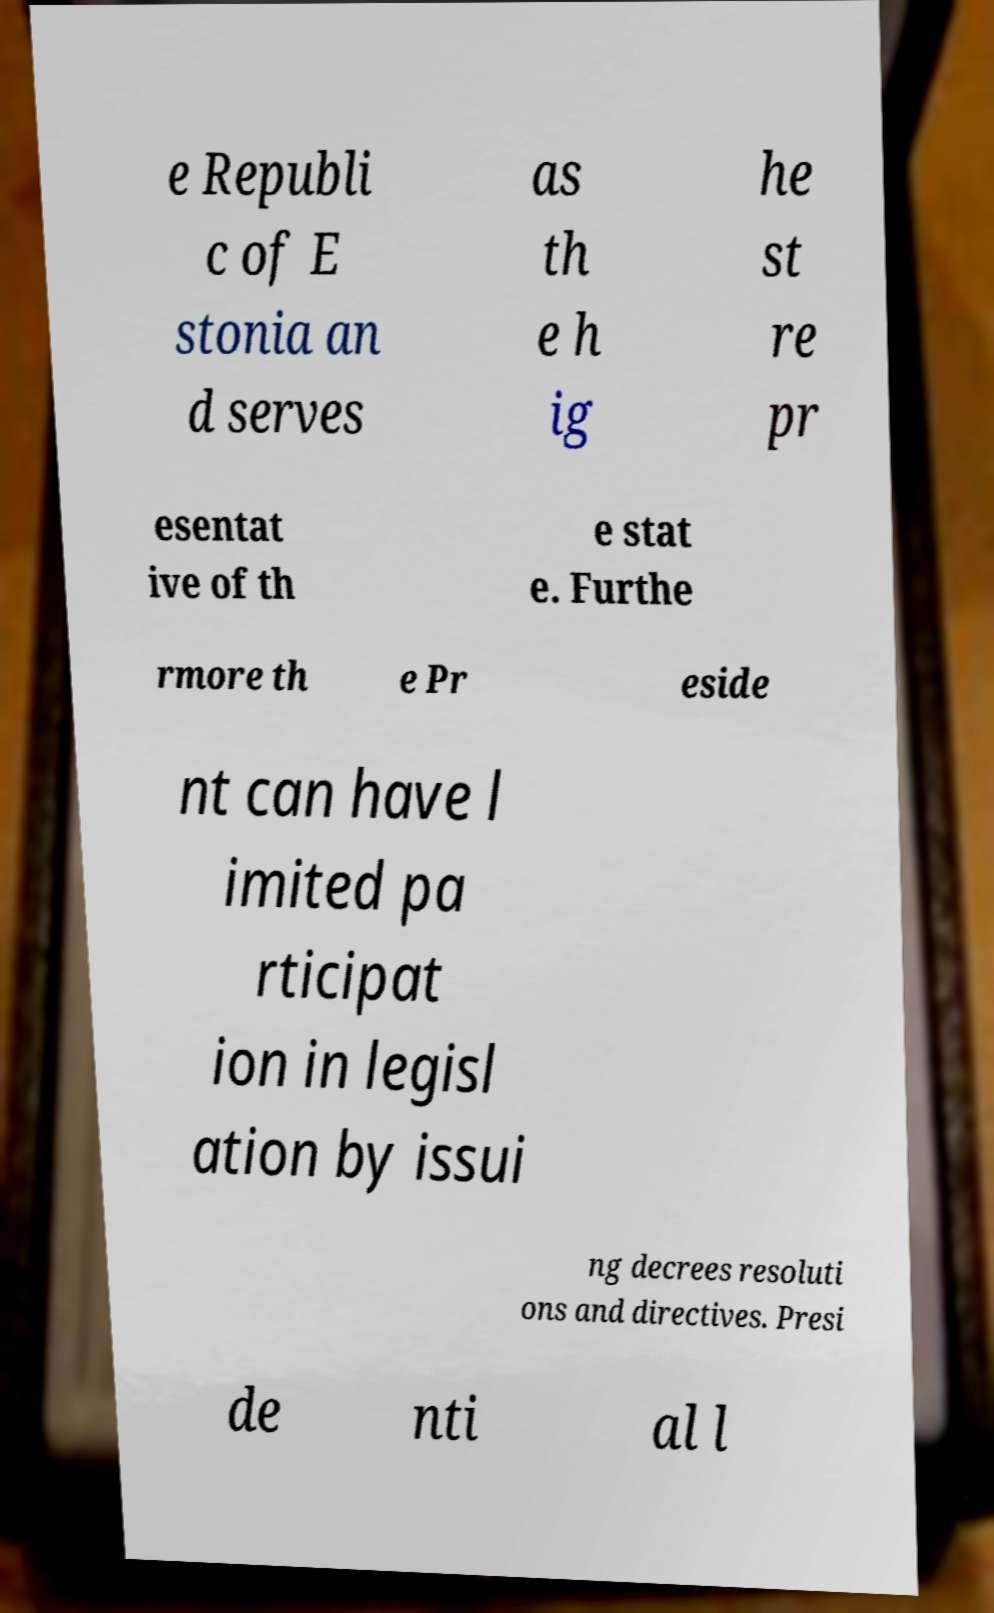What messages or text are displayed in this image? I need them in a readable, typed format. e Republi c of E stonia an d serves as th e h ig he st re pr esentat ive of th e stat e. Furthe rmore th e Pr eside nt can have l imited pa rticipat ion in legisl ation by issui ng decrees resoluti ons and directives. Presi de nti al l 